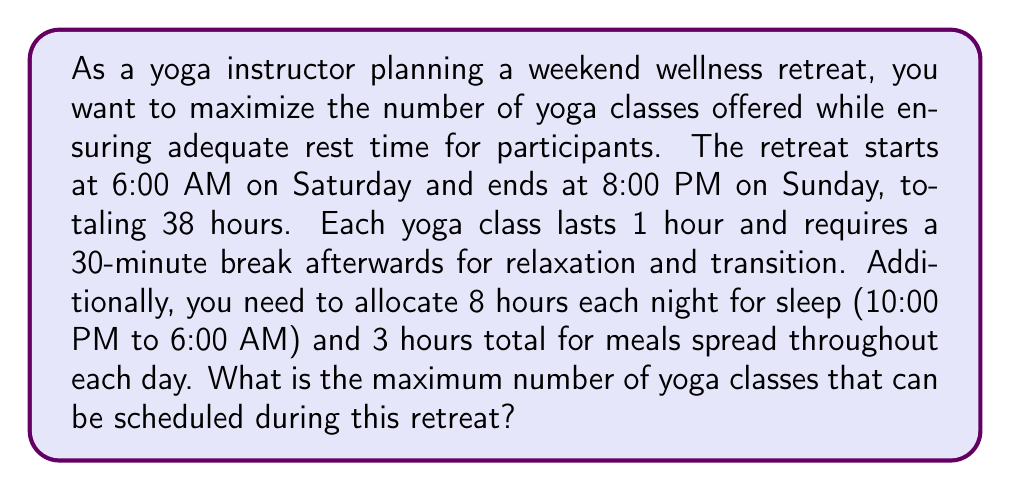Give your solution to this math problem. Let's approach this step-by-step:

1) First, calculate the total available time:
   Total time = 38 hours

2) Subtract the time allocated for sleep:
   Available time = 38 - (2 * 8) = 22 hours

3) Subtract the time allocated for meals:
   Available time = 22 - 3 = 19 hours

4) Now, we need to determine how much time each yoga class takes, including the break:
   Time per class = 1 hour (class) + 0.5 hours (break) = 1.5 hours

5) To find the maximum number of classes, we divide the available time by the time per class:
   
   $$\text{Maximum classes} = \left\lfloor\frac{\text{Available time}}{\text{Time per class}}\right\rfloor$$

   $$= \left\lfloor\frac{19}{1.5}\right\rfloor$$

   $$= \left\lfloor12.6666...\right\rfloor$$

   $$= 12$$

The floor function $\lfloor \rfloor$ is used because we can only schedule whole classes.

Therefore, the maximum number of yoga classes that can be scheduled is 12.

6) Verify:
   12 classes * 1.5 hours = 18 hours
   This leaves 1 hour of flexible time, which is less than the 1.5 hours needed for another full class.
Answer: The maximum number of yoga classes that can be scheduled during the retreat is 12. 